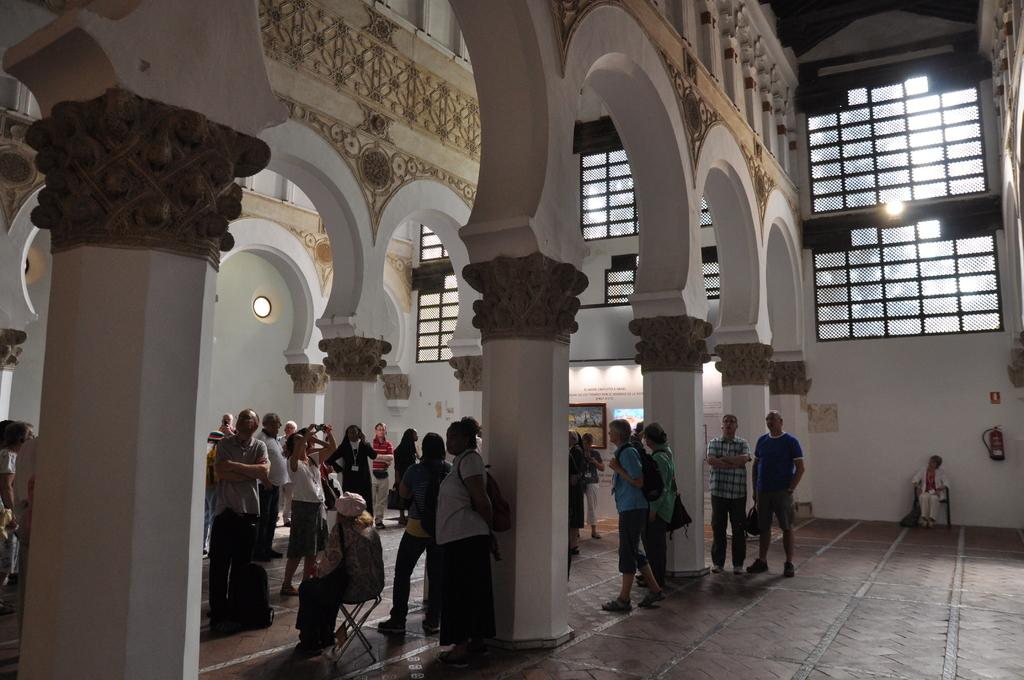How many people are in the image? There is a group of people in the image, but the exact number is not specified. What are the people in the image doing? Some people are standing on the floor, and some are sitting on chairs. What architectural features can be seen in the image? There are pillars and frames visible in the image. What safety equipment is present in the image? There is a fire extinguisher in the image. What can be seen in the background of the image? There are windows visible in the background. What type of plantation is visible in the image? There is no plantation present in the image. How does the image change over time? The image itself does not change over time; it is a static representation of the scene. 